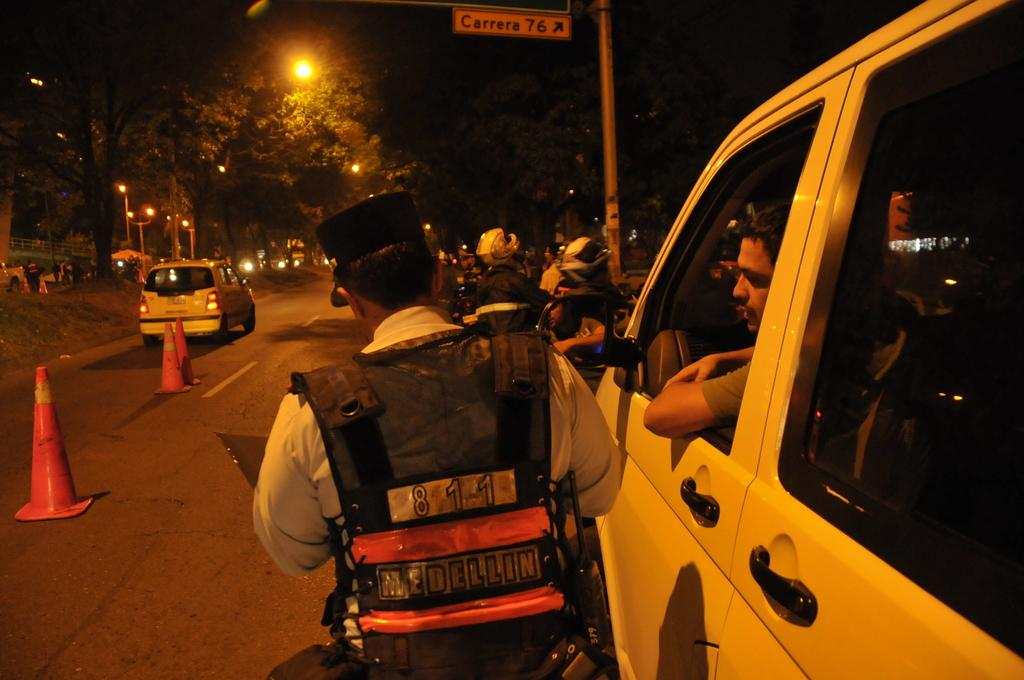<image>
Present a compact description of the photo's key features. The officer shown has Medellin written on their back. 